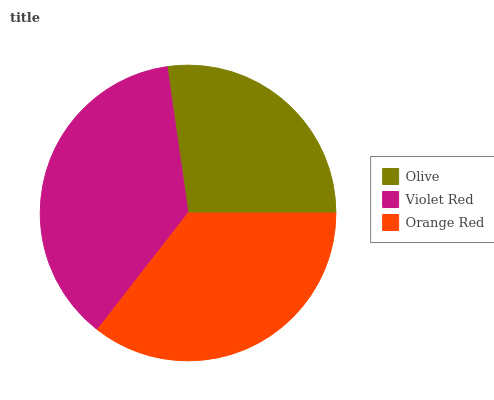Is Olive the minimum?
Answer yes or no. Yes. Is Violet Red the maximum?
Answer yes or no. Yes. Is Orange Red the minimum?
Answer yes or no. No. Is Orange Red the maximum?
Answer yes or no. No. Is Violet Red greater than Orange Red?
Answer yes or no. Yes. Is Orange Red less than Violet Red?
Answer yes or no. Yes. Is Orange Red greater than Violet Red?
Answer yes or no. No. Is Violet Red less than Orange Red?
Answer yes or no. No. Is Orange Red the high median?
Answer yes or no. Yes. Is Orange Red the low median?
Answer yes or no. Yes. Is Olive the high median?
Answer yes or no. No. Is Violet Red the low median?
Answer yes or no. No. 